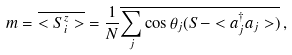Convert formula to latex. <formula><loc_0><loc_0><loc_500><loc_500>m = \overline { < S ^ { z } _ { i } > } = \frac { 1 } { N } \overline { \sum _ { j } \cos \theta _ { j } ( S - < a _ { j } ^ { \dagger } a _ { j } > ) } \, ,</formula> 